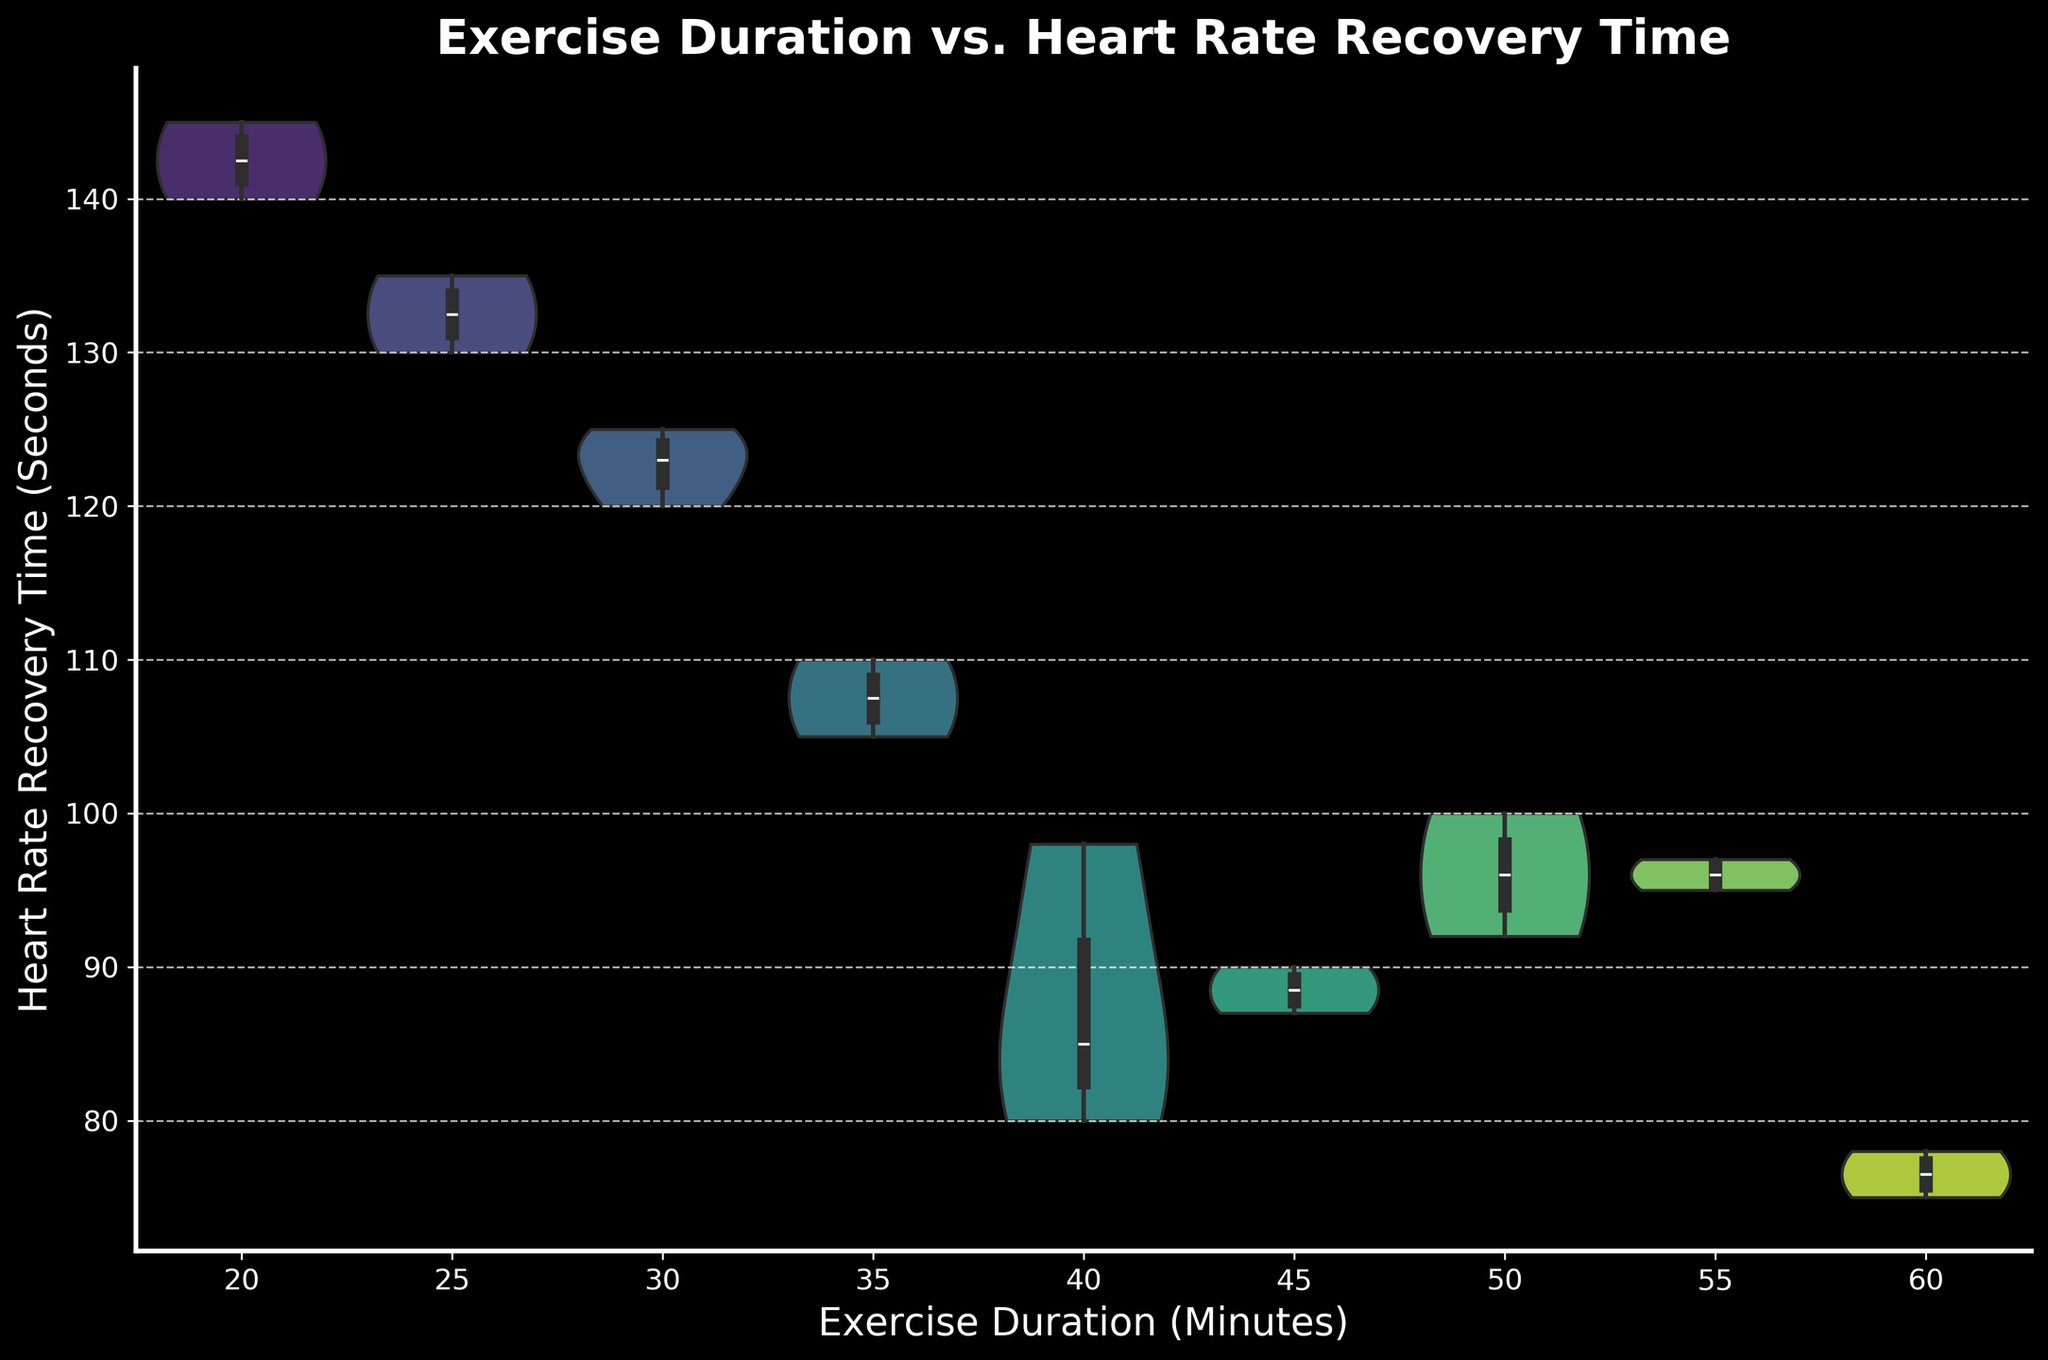What is the title of the violin chart? The title of the chart is usually found at the top of the figure and provides an overview of what the chart is about.
Answer: Exercise Duration vs. Heart Rate Recovery Time What are the labels for the x-axis and y-axis? The labels for the axes provide context for the data being plotted. Check the horizontal and vertical sides of the figure.
Answer: x-axis: Exercise Duration (Minutes), y-axis: Heart Rate Recovery Time (Seconds) How many unique Exercise Duration groups are shown? Unique groups in the x-axis can be identified by distinct tick marks or categories on the x-axis.
Answer: 7 Which exercise duration group appears to have the widest distribution in heart rate recovery times? The width of the violin plot at any given point indicates the density of data points at that range. Check for the widest part among the groups.
Answer: 40 Minutes Which group has the smallest median heart rate recovery time? The median is indicated by the central line in the inner box plot inside the violin plot.
Answer: 60 Minutes Are the heart rate recovery times generally lower for higher exercise durations? Compare the central tendency (median) and the spread of the data points across different exercise durations to determine general trends.
Answer: Yes Which exercise duration groups have a bimodal distribution? Bimodal distributions appear as violin plots with two distinct peaks. Carefully observe the shapes of the violin plots.
Answer: None In which exercise duration group are the heart rate recovery times most compact (least spread out)? The group with the narrowest violin plot indicates the least variability in heart rate recovery times.
Answer: 60 Minutes Comparing the 30-minute and 45-minute exercise groups, which has a lower median heart rate recovery time? Look at the inner box plot’s central line for both the 30-minute and 45-minute groups to compare median values.
Answer: 45 Minutes How does the density of heart rate recovery times for the 50-minute group compare to that of the 25-minute group? Compare the width and shape of the violin plots for the 50-minute and 25-minute groups to assess the density of data points at different ranges.
Answer: 50-minute group is more compact and centered around a narrower range of heart rate recovery times compared to the 25-minute group 